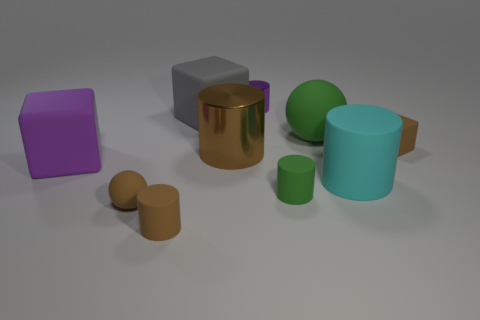Subtract all small rubber blocks. How many blocks are left? 2 Subtract all purple blocks. How many blocks are left? 2 Subtract all balls. How many objects are left? 8 Add 3 small cylinders. How many small cylinders exist? 6 Subtract 0 green cubes. How many objects are left? 10 Subtract 1 spheres. How many spheres are left? 1 Subtract all gray blocks. Subtract all green cylinders. How many blocks are left? 2 Subtract all red cubes. How many brown balls are left? 1 Subtract all brown shiny cylinders. Subtract all big cyan objects. How many objects are left? 8 Add 4 green things. How many green things are left? 6 